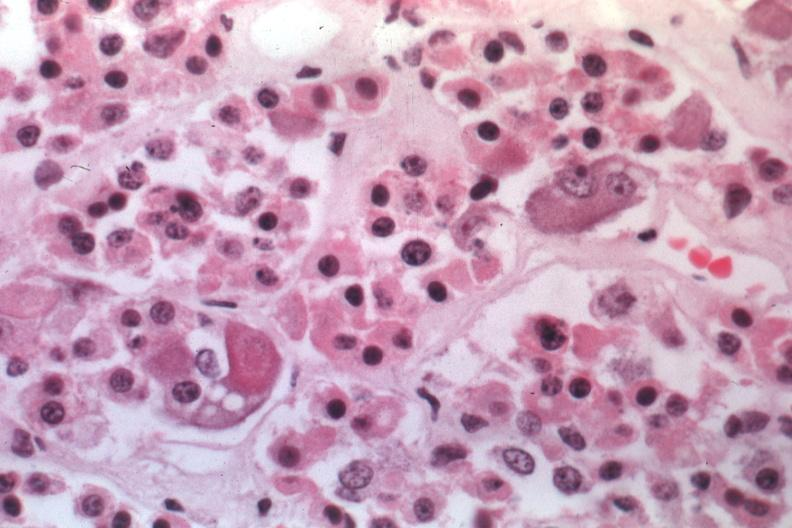s situs inversus present?
Answer the question using a single word or phrase. No 